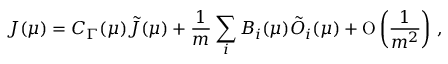<formula> <loc_0><loc_0><loc_500><loc_500>J ( \mu ) = C _ { \Gamma } ( \mu ) \tilde { J } ( \mu ) + \frac { 1 } m } \sum _ { i } B _ { i } ( \mu ) \tilde { O } _ { i } ( \mu ) + O \left ( \frac { 1 } m ^ { 2 } } \right ) \, ,</formula> 